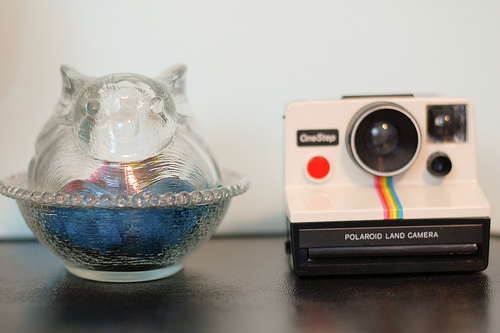<image>
Is there a bowl to the right of the camera? No. The bowl is not to the right of the camera. The horizontal positioning shows a different relationship. Where is the polaroid in relation to the cup? Is it next to the cup? Yes. The polaroid is positioned adjacent to the cup, located nearby in the same general area. 